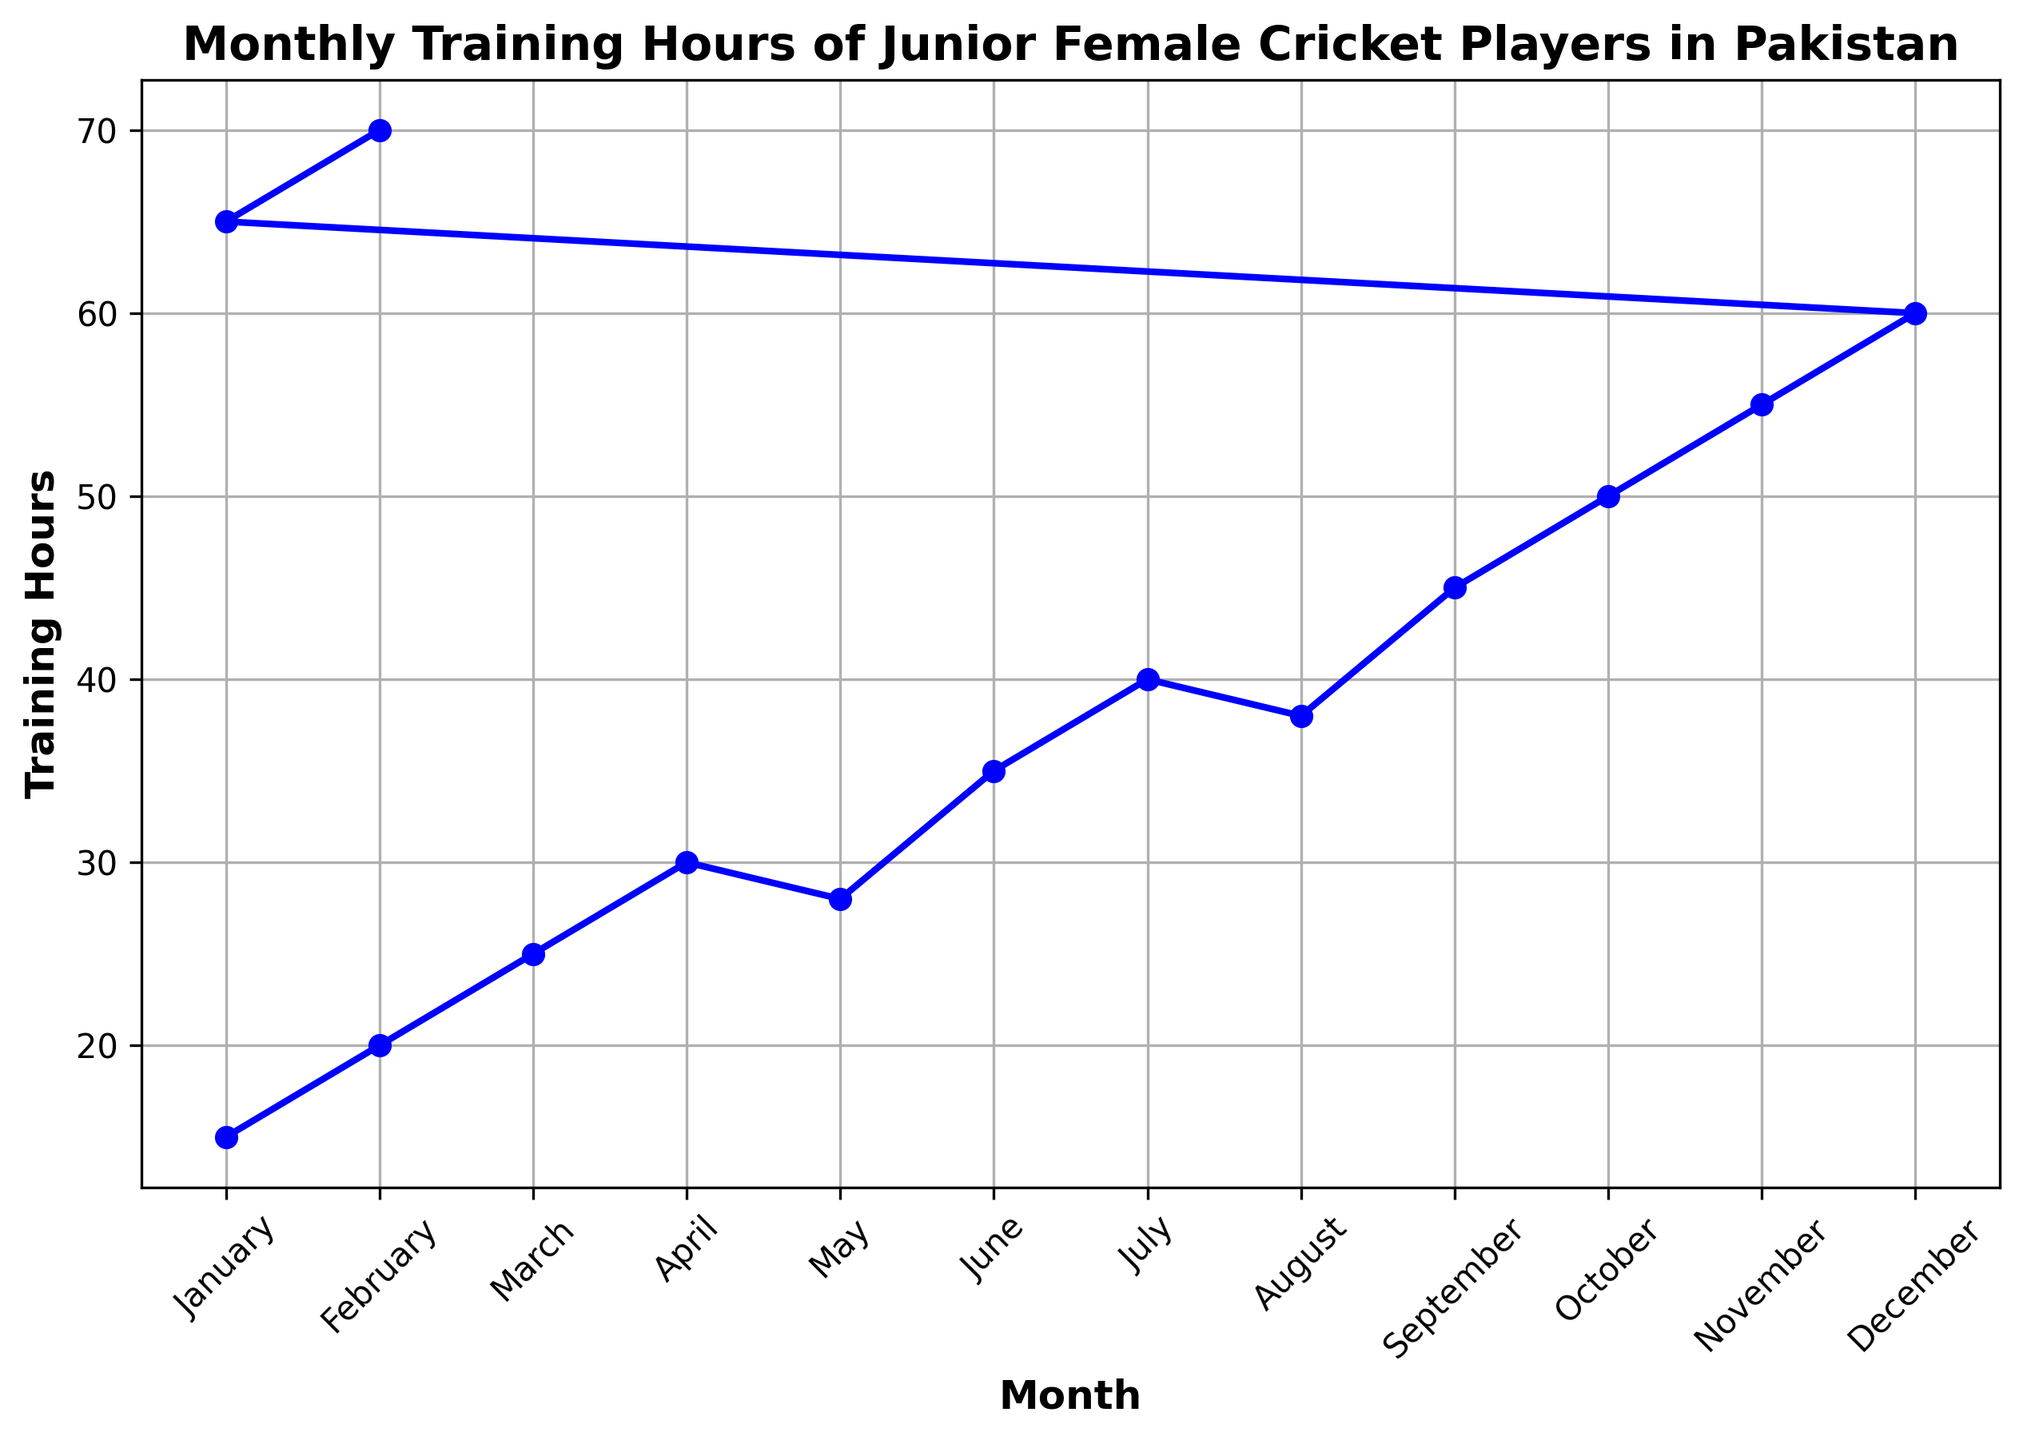What is the difference in training hours between January and February of the first year? In January of the first year, the training hours are 15, and in February, they are 20. The difference is 20 - 15 = 5 hours.
Answer: 5 hours Which month shows the highest increase in training hours? To find the highest increase, look at the differences between consecutive months. September to October has the highest increase of 50 - 45 = 5 hours.
Answer: October Over the two years, what is the average monthly training hours? Sum all the training hours over the two years and divide by the number of months (14). The total training hours are 601, so the average is 601 / 14 ≈ 43 hours.
Answer: ≈ 43 hours In which months did the training hours decrease compared to the previous month? Look for months where the training hours are lower than the previous month. May (28 from April’s 30) and August (38 from July’s 40) are the months where training hours decreased.
Answer: May, August How many months had training hours above 50? Count the months with training hours above 50. These are November, December, January (second year), and February (second year).
Answer: 4 months What is the total training hours in the second year? Sum the training hours from January of the second year to February of the second year. They sum up to 320 hours.
Answer: 320 hours Compare the trend of training hours in the first half of the first year to the first half of the second year. Which one shows more consistent improvement? The first half of the first year shows a steady increase from 15 to 35 hours. In the second year, training hours increase from 65 to 70 hours, showing a more consistent and smaller increase. So, the second year shows a more consistent trend.
Answer: Second year Which month in the two years had the maximum training hours? The month with the highest training hours is February of the second year with 70 hours.
Answer: February (second year) Calculate the total increase in training hours from January of the first year to January of the second year. The total increase is found by subtracting the training hours in January of the first year from January of the second year, which is 65 - 15 = 50 hours.
Answer: 50 hours What is the median of the monthly training hours over the two-year period? To find the median, list the training hours in ascending order and find the middle value. For 14 values, the median is the average of the 7th and 8th values, which are 35 and 38. Median = (35 + 38) / 2 = 36.5 hours.
Answer: 36.5 hours 